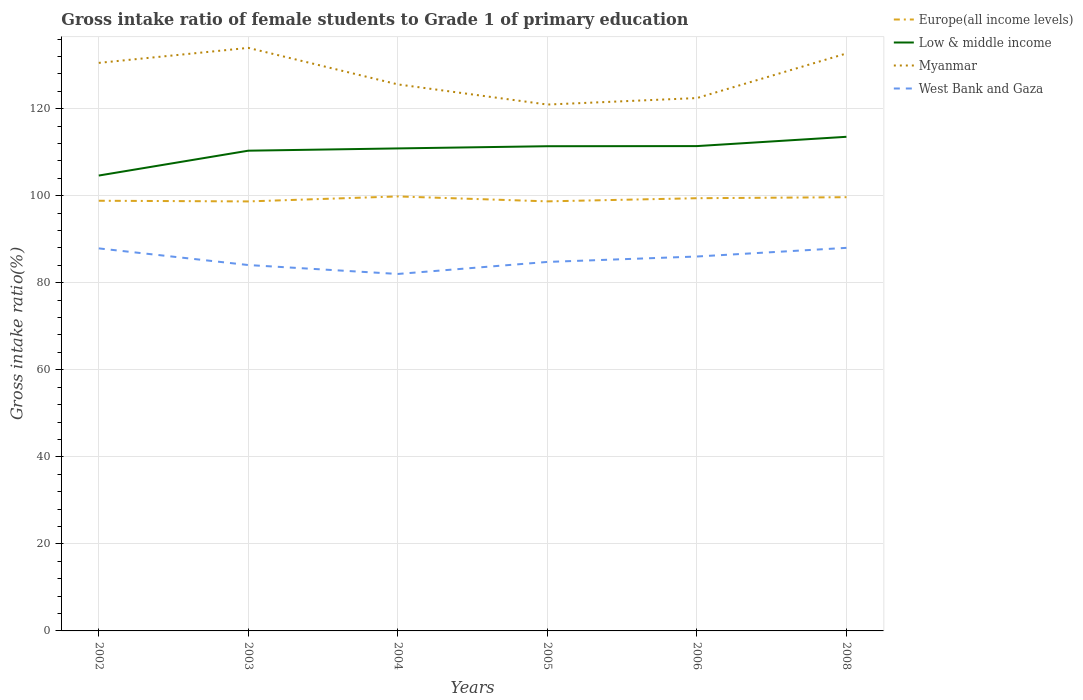How many different coloured lines are there?
Your answer should be compact. 4. Is the number of lines equal to the number of legend labels?
Offer a terse response. Yes. Across all years, what is the maximum gross intake ratio in Europe(all income levels)?
Give a very brief answer. 98.68. What is the total gross intake ratio in Low & middle income in the graph?
Keep it short and to the point. -1.03. What is the difference between the highest and the second highest gross intake ratio in Myanmar?
Offer a very short reply. 13.02. What is the difference between the highest and the lowest gross intake ratio in Low & middle income?
Provide a succinct answer. 4. Is the gross intake ratio in West Bank and Gaza strictly greater than the gross intake ratio in Myanmar over the years?
Give a very brief answer. Yes. How many years are there in the graph?
Ensure brevity in your answer.  6. What is the difference between two consecutive major ticks on the Y-axis?
Offer a very short reply. 20. Are the values on the major ticks of Y-axis written in scientific E-notation?
Keep it short and to the point. No. Does the graph contain grids?
Offer a terse response. Yes. Where does the legend appear in the graph?
Your answer should be very brief. Top right. How many legend labels are there?
Give a very brief answer. 4. What is the title of the graph?
Offer a very short reply. Gross intake ratio of female students to Grade 1 of primary education. What is the label or title of the Y-axis?
Provide a succinct answer. Gross intake ratio(%). What is the Gross intake ratio(%) of Europe(all income levels) in 2002?
Your answer should be very brief. 98.84. What is the Gross intake ratio(%) in Low & middle income in 2002?
Provide a short and direct response. 104.63. What is the Gross intake ratio(%) in Myanmar in 2002?
Give a very brief answer. 130.52. What is the Gross intake ratio(%) in West Bank and Gaza in 2002?
Your response must be concise. 87.89. What is the Gross intake ratio(%) in Europe(all income levels) in 2003?
Give a very brief answer. 98.68. What is the Gross intake ratio(%) in Low & middle income in 2003?
Give a very brief answer. 110.34. What is the Gross intake ratio(%) of Myanmar in 2003?
Keep it short and to the point. 133.96. What is the Gross intake ratio(%) in West Bank and Gaza in 2003?
Offer a terse response. 84.07. What is the Gross intake ratio(%) in Europe(all income levels) in 2004?
Give a very brief answer. 99.83. What is the Gross intake ratio(%) of Low & middle income in 2004?
Offer a very short reply. 110.86. What is the Gross intake ratio(%) in Myanmar in 2004?
Offer a very short reply. 125.57. What is the Gross intake ratio(%) of West Bank and Gaza in 2004?
Your response must be concise. 82.02. What is the Gross intake ratio(%) of Europe(all income levels) in 2005?
Your response must be concise. 98.7. What is the Gross intake ratio(%) in Low & middle income in 2005?
Offer a terse response. 111.37. What is the Gross intake ratio(%) of Myanmar in 2005?
Provide a succinct answer. 120.94. What is the Gross intake ratio(%) of West Bank and Gaza in 2005?
Your answer should be very brief. 84.78. What is the Gross intake ratio(%) of Europe(all income levels) in 2006?
Keep it short and to the point. 99.42. What is the Gross intake ratio(%) in Low & middle income in 2006?
Offer a very short reply. 111.4. What is the Gross intake ratio(%) in Myanmar in 2006?
Provide a succinct answer. 122.43. What is the Gross intake ratio(%) of West Bank and Gaza in 2006?
Offer a terse response. 86.03. What is the Gross intake ratio(%) in Europe(all income levels) in 2008?
Your response must be concise. 99.66. What is the Gross intake ratio(%) in Low & middle income in 2008?
Your response must be concise. 113.53. What is the Gross intake ratio(%) of Myanmar in 2008?
Provide a short and direct response. 132.68. What is the Gross intake ratio(%) of West Bank and Gaza in 2008?
Your answer should be very brief. 88.01. Across all years, what is the maximum Gross intake ratio(%) of Europe(all income levels)?
Make the answer very short. 99.83. Across all years, what is the maximum Gross intake ratio(%) in Low & middle income?
Your answer should be compact. 113.53. Across all years, what is the maximum Gross intake ratio(%) of Myanmar?
Keep it short and to the point. 133.96. Across all years, what is the maximum Gross intake ratio(%) of West Bank and Gaza?
Your answer should be compact. 88.01. Across all years, what is the minimum Gross intake ratio(%) of Europe(all income levels)?
Offer a very short reply. 98.68. Across all years, what is the minimum Gross intake ratio(%) of Low & middle income?
Your answer should be very brief. 104.63. Across all years, what is the minimum Gross intake ratio(%) in Myanmar?
Your answer should be compact. 120.94. Across all years, what is the minimum Gross intake ratio(%) in West Bank and Gaza?
Your response must be concise. 82.02. What is the total Gross intake ratio(%) in Europe(all income levels) in the graph?
Offer a very short reply. 595.13. What is the total Gross intake ratio(%) of Low & middle income in the graph?
Your answer should be compact. 662.13. What is the total Gross intake ratio(%) of Myanmar in the graph?
Your answer should be compact. 766.11. What is the total Gross intake ratio(%) in West Bank and Gaza in the graph?
Provide a short and direct response. 512.8. What is the difference between the Gross intake ratio(%) in Europe(all income levels) in 2002 and that in 2003?
Give a very brief answer. 0.15. What is the difference between the Gross intake ratio(%) of Low & middle income in 2002 and that in 2003?
Ensure brevity in your answer.  -5.71. What is the difference between the Gross intake ratio(%) in Myanmar in 2002 and that in 2003?
Keep it short and to the point. -3.45. What is the difference between the Gross intake ratio(%) in West Bank and Gaza in 2002 and that in 2003?
Keep it short and to the point. 3.83. What is the difference between the Gross intake ratio(%) in Europe(all income levels) in 2002 and that in 2004?
Ensure brevity in your answer.  -0.99. What is the difference between the Gross intake ratio(%) in Low & middle income in 2002 and that in 2004?
Keep it short and to the point. -6.23. What is the difference between the Gross intake ratio(%) in Myanmar in 2002 and that in 2004?
Give a very brief answer. 4.94. What is the difference between the Gross intake ratio(%) of West Bank and Gaza in 2002 and that in 2004?
Provide a short and direct response. 5.88. What is the difference between the Gross intake ratio(%) of Europe(all income levels) in 2002 and that in 2005?
Provide a short and direct response. 0.14. What is the difference between the Gross intake ratio(%) of Low & middle income in 2002 and that in 2005?
Offer a terse response. -6.74. What is the difference between the Gross intake ratio(%) of Myanmar in 2002 and that in 2005?
Your answer should be compact. 9.57. What is the difference between the Gross intake ratio(%) in West Bank and Gaza in 2002 and that in 2005?
Ensure brevity in your answer.  3.11. What is the difference between the Gross intake ratio(%) in Europe(all income levels) in 2002 and that in 2006?
Give a very brief answer. -0.58. What is the difference between the Gross intake ratio(%) in Low & middle income in 2002 and that in 2006?
Your response must be concise. -6.77. What is the difference between the Gross intake ratio(%) of Myanmar in 2002 and that in 2006?
Provide a short and direct response. 8.08. What is the difference between the Gross intake ratio(%) in West Bank and Gaza in 2002 and that in 2006?
Your response must be concise. 1.87. What is the difference between the Gross intake ratio(%) in Europe(all income levels) in 2002 and that in 2008?
Provide a succinct answer. -0.82. What is the difference between the Gross intake ratio(%) in Low & middle income in 2002 and that in 2008?
Offer a very short reply. -8.9. What is the difference between the Gross intake ratio(%) of Myanmar in 2002 and that in 2008?
Your answer should be very brief. -2.17. What is the difference between the Gross intake ratio(%) in West Bank and Gaza in 2002 and that in 2008?
Make the answer very short. -0.12. What is the difference between the Gross intake ratio(%) in Europe(all income levels) in 2003 and that in 2004?
Give a very brief answer. -1.15. What is the difference between the Gross intake ratio(%) in Low & middle income in 2003 and that in 2004?
Your response must be concise. -0.52. What is the difference between the Gross intake ratio(%) in Myanmar in 2003 and that in 2004?
Offer a terse response. 8.39. What is the difference between the Gross intake ratio(%) in West Bank and Gaza in 2003 and that in 2004?
Your answer should be compact. 2.05. What is the difference between the Gross intake ratio(%) in Europe(all income levels) in 2003 and that in 2005?
Offer a very short reply. -0.01. What is the difference between the Gross intake ratio(%) in Low & middle income in 2003 and that in 2005?
Give a very brief answer. -1.03. What is the difference between the Gross intake ratio(%) in Myanmar in 2003 and that in 2005?
Give a very brief answer. 13.02. What is the difference between the Gross intake ratio(%) of West Bank and Gaza in 2003 and that in 2005?
Make the answer very short. -0.71. What is the difference between the Gross intake ratio(%) in Europe(all income levels) in 2003 and that in 2006?
Ensure brevity in your answer.  -0.74. What is the difference between the Gross intake ratio(%) in Low & middle income in 2003 and that in 2006?
Give a very brief answer. -1.06. What is the difference between the Gross intake ratio(%) of Myanmar in 2003 and that in 2006?
Provide a short and direct response. 11.53. What is the difference between the Gross intake ratio(%) of West Bank and Gaza in 2003 and that in 2006?
Make the answer very short. -1.96. What is the difference between the Gross intake ratio(%) in Europe(all income levels) in 2003 and that in 2008?
Make the answer very short. -0.97. What is the difference between the Gross intake ratio(%) of Low & middle income in 2003 and that in 2008?
Offer a terse response. -3.19. What is the difference between the Gross intake ratio(%) of Myanmar in 2003 and that in 2008?
Offer a terse response. 1.28. What is the difference between the Gross intake ratio(%) in West Bank and Gaza in 2003 and that in 2008?
Ensure brevity in your answer.  -3.95. What is the difference between the Gross intake ratio(%) in Europe(all income levels) in 2004 and that in 2005?
Provide a succinct answer. 1.14. What is the difference between the Gross intake ratio(%) in Low & middle income in 2004 and that in 2005?
Make the answer very short. -0.51. What is the difference between the Gross intake ratio(%) of Myanmar in 2004 and that in 2005?
Ensure brevity in your answer.  4.63. What is the difference between the Gross intake ratio(%) in West Bank and Gaza in 2004 and that in 2005?
Keep it short and to the point. -2.76. What is the difference between the Gross intake ratio(%) in Europe(all income levels) in 2004 and that in 2006?
Ensure brevity in your answer.  0.41. What is the difference between the Gross intake ratio(%) of Low & middle income in 2004 and that in 2006?
Provide a succinct answer. -0.53. What is the difference between the Gross intake ratio(%) of Myanmar in 2004 and that in 2006?
Ensure brevity in your answer.  3.14. What is the difference between the Gross intake ratio(%) of West Bank and Gaza in 2004 and that in 2006?
Provide a succinct answer. -4.01. What is the difference between the Gross intake ratio(%) of Europe(all income levels) in 2004 and that in 2008?
Make the answer very short. 0.18. What is the difference between the Gross intake ratio(%) of Low & middle income in 2004 and that in 2008?
Provide a short and direct response. -2.67. What is the difference between the Gross intake ratio(%) in Myanmar in 2004 and that in 2008?
Ensure brevity in your answer.  -7.11. What is the difference between the Gross intake ratio(%) of West Bank and Gaza in 2004 and that in 2008?
Offer a terse response. -6. What is the difference between the Gross intake ratio(%) of Europe(all income levels) in 2005 and that in 2006?
Your answer should be very brief. -0.72. What is the difference between the Gross intake ratio(%) in Low & middle income in 2005 and that in 2006?
Offer a terse response. -0.03. What is the difference between the Gross intake ratio(%) of Myanmar in 2005 and that in 2006?
Offer a very short reply. -1.49. What is the difference between the Gross intake ratio(%) of West Bank and Gaza in 2005 and that in 2006?
Offer a very short reply. -1.24. What is the difference between the Gross intake ratio(%) in Europe(all income levels) in 2005 and that in 2008?
Offer a very short reply. -0.96. What is the difference between the Gross intake ratio(%) in Low & middle income in 2005 and that in 2008?
Your answer should be very brief. -2.16. What is the difference between the Gross intake ratio(%) of Myanmar in 2005 and that in 2008?
Keep it short and to the point. -11.74. What is the difference between the Gross intake ratio(%) in West Bank and Gaza in 2005 and that in 2008?
Your answer should be very brief. -3.23. What is the difference between the Gross intake ratio(%) of Europe(all income levels) in 2006 and that in 2008?
Your response must be concise. -0.23. What is the difference between the Gross intake ratio(%) in Low & middle income in 2006 and that in 2008?
Provide a short and direct response. -2.14. What is the difference between the Gross intake ratio(%) in Myanmar in 2006 and that in 2008?
Offer a terse response. -10.25. What is the difference between the Gross intake ratio(%) of West Bank and Gaza in 2006 and that in 2008?
Offer a very short reply. -1.99. What is the difference between the Gross intake ratio(%) of Europe(all income levels) in 2002 and the Gross intake ratio(%) of Low & middle income in 2003?
Your answer should be very brief. -11.5. What is the difference between the Gross intake ratio(%) of Europe(all income levels) in 2002 and the Gross intake ratio(%) of Myanmar in 2003?
Your answer should be very brief. -35.12. What is the difference between the Gross intake ratio(%) of Europe(all income levels) in 2002 and the Gross intake ratio(%) of West Bank and Gaza in 2003?
Ensure brevity in your answer.  14.77. What is the difference between the Gross intake ratio(%) of Low & middle income in 2002 and the Gross intake ratio(%) of Myanmar in 2003?
Your answer should be very brief. -29.33. What is the difference between the Gross intake ratio(%) in Low & middle income in 2002 and the Gross intake ratio(%) in West Bank and Gaza in 2003?
Your response must be concise. 20.56. What is the difference between the Gross intake ratio(%) in Myanmar in 2002 and the Gross intake ratio(%) in West Bank and Gaza in 2003?
Offer a terse response. 46.45. What is the difference between the Gross intake ratio(%) of Europe(all income levels) in 2002 and the Gross intake ratio(%) of Low & middle income in 2004?
Your response must be concise. -12.03. What is the difference between the Gross intake ratio(%) of Europe(all income levels) in 2002 and the Gross intake ratio(%) of Myanmar in 2004?
Keep it short and to the point. -26.73. What is the difference between the Gross intake ratio(%) of Europe(all income levels) in 2002 and the Gross intake ratio(%) of West Bank and Gaza in 2004?
Your answer should be compact. 16.82. What is the difference between the Gross intake ratio(%) of Low & middle income in 2002 and the Gross intake ratio(%) of Myanmar in 2004?
Offer a very short reply. -20.94. What is the difference between the Gross intake ratio(%) of Low & middle income in 2002 and the Gross intake ratio(%) of West Bank and Gaza in 2004?
Your answer should be very brief. 22.61. What is the difference between the Gross intake ratio(%) in Myanmar in 2002 and the Gross intake ratio(%) in West Bank and Gaza in 2004?
Ensure brevity in your answer.  48.5. What is the difference between the Gross intake ratio(%) in Europe(all income levels) in 2002 and the Gross intake ratio(%) in Low & middle income in 2005?
Give a very brief answer. -12.53. What is the difference between the Gross intake ratio(%) of Europe(all income levels) in 2002 and the Gross intake ratio(%) of Myanmar in 2005?
Offer a very short reply. -22.1. What is the difference between the Gross intake ratio(%) of Europe(all income levels) in 2002 and the Gross intake ratio(%) of West Bank and Gaza in 2005?
Keep it short and to the point. 14.06. What is the difference between the Gross intake ratio(%) in Low & middle income in 2002 and the Gross intake ratio(%) in Myanmar in 2005?
Keep it short and to the point. -16.31. What is the difference between the Gross intake ratio(%) of Low & middle income in 2002 and the Gross intake ratio(%) of West Bank and Gaza in 2005?
Offer a very short reply. 19.85. What is the difference between the Gross intake ratio(%) of Myanmar in 2002 and the Gross intake ratio(%) of West Bank and Gaza in 2005?
Keep it short and to the point. 45.73. What is the difference between the Gross intake ratio(%) in Europe(all income levels) in 2002 and the Gross intake ratio(%) in Low & middle income in 2006?
Provide a short and direct response. -12.56. What is the difference between the Gross intake ratio(%) in Europe(all income levels) in 2002 and the Gross intake ratio(%) in Myanmar in 2006?
Provide a succinct answer. -23.6. What is the difference between the Gross intake ratio(%) in Europe(all income levels) in 2002 and the Gross intake ratio(%) in West Bank and Gaza in 2006?
Provide a succinct answer. 12.81. What is the difference between the Gross intake ratio(%) of Low & middle income in 2002 and the Gross intake ratio(%) of Myanmar in 2006?
Your answer should be very brief. -17.81. What is the difference between the Gross intake ratio(%) of Low & middle income in 2002 and the Gross intake ratio(%) of West Bank and Gaza in 2006?
Your response must be concise. 18.6. What is the difference between the Gross intake ratio(%) of Myanmar in 2002 and the Gross intake ratio(%) of West Bank and Gaza in 2006?
Make the answer very short. 44.49. What is the difference between the Gross intake ratio(%) of Europe(all income levels) in 2002 and the Gross intake ratio(%) of Low & middle income in 2008?
Your response must be concise. -14.69. What is the difference between the Gross intake ratio(%) in Europe(all income levels) in 2002 and the Gross intake ratio(%) in Myanmar in 2008?
Make the answer very short. -33.84. What is the difference between the Gross intake ratio(%) in Europe(all income levels) in 2002 and the Gross intake ratio(%) in West Bank and Gaza in 2008?
Offer a very short reply. 10.82. What is the difference between the Gross intake ratio(%) of Low & middle income in 2002 and the Gross intake ratio(%) of Myanmar in 2008?
Provide a short and direct response. -28.05. What is the difference between the Gross intake ratio(%) in Low & middle income in 2002 and the Gross intake ratio(%) in West Bank and Gaza in 2008?
Keep it short and to the point. 16.61. What is the difference between the Gross intake ratio(%) of Myanmar in 2002 and the Gross intake ratio(%) of West Bank and Gaza in 2008?
Provide a succinct answer. 42.5. What is the difference between the Gross intake ratio(%) of Europe(all income levels) in 2003 and the Gross intake ratio(%) of Low & middle income in 2004?
Your answer should be very brief. -12.18. What is the difference between the Gross intake ratio(%) in Europe(all income levels) in 2003 and the Gross intake ratio(%) in Myanmar in 2004?
Offer a very short reply. -26.89. What is the difference between the Gross intake ratio(%) in Europe(all income levels) in 2003 and the Gross intake ratio(%) in West Bank and Gaza in 2004?
Make the answer very short. 16.67. What is the difference between the Gross intake ratio(%) in Low & middle income in 2003 and the Gross intake ratio(%) in Myanmar in 2004?
Provide a short and direct response. -15.23. What is the difference between the Gross intake ratio(%) in Low & middle income in 2003 and the Gross intake ratio(%) in West Bank and Gaza in 2004?
Offer a very short reply. 28.32. What is the difference between the Gross intake ratio(%) of Myanmar in 2003 and the Gross intake ratio(%) of West Bank and Gaza in 2004?
Make the answer very short. 51.95. What is the difference between the Gross intake ratio(%) of Europe(all income levels) in 2003 and the Gross intake ratio(%) of Low & middle income in 2005?
Provide a succinct answer. -12.69. What is the difference between the Gross intake ratio(%) in Europe(all income levels) in 2003 and the Gross intake ratio(%) in Myanmar in 2005?
Ensure brevity in your answer.  -22.26. What is the difference between the Gross intake ratio(%) in Europe(all income levels) in 2003 and the Gross intake ratio(%) in West Bank and Gaza in 2005?
Provide a succinct answer. 13.9. What is the difference between the Gross intake ratio(%) in Low & middle income in 2003 and the Gross intake ratio(%) in Myanmar in 2005?
Provide a succinct answer. -10.6. What is the difference between the Gross intake ratio(%) of Low & middle income in 2003 and the Gross intake ratio(%) of West Bank and Gaza in 2005?
Your response must be concise. 25.56. What is the difference between the Gross intake ratio(%) in Myanmar in 2003 and the Gross intake ratio(%) in West Bank and Gaza in 2005?
Keep it short and to the point. 49.18. What is the difference between the Gross intake ratio(%) in Europe(all income levels) in 2003 and the Gross intake ratio(%) in Low & middle income in 2006?
Ensure brevity in your answer.  -12.71. What is the difference between the Gross intake ratio(%) in Europe(all income levels) in 2003 and the Gross intake ratio(%) in Myanmar in 2006?
Your answer should be compact. -23.75. What is the difference between the Gross intake ratio(%) in Europe(all income levels) in 2003 and the Gross intake ratio(%) in West Bank and Gaza in 2006?
Offer a very short reply. 12.66. What is the difference between the Gross intake ratio(%) in Low & middle income in 2003 and the Gross intake ratio(%) in Myanmar in 2006?
Offer a very short reply. -12.09. What is the difference between the Gross intake ratio(%) in Low & middle income in 2003 and the Gross intake ratio(%) in West Bank and Gaza in 2006?
Ensure brevity in your answer.  24.32. What is the difference between the Gross intake ratio(%) in Myanmar in 2003 and the Gross intake ratio(%) in West Bank and Gaza in 2006?
Keep it short and to the point. 47.94. What is the difference between the Gross intake ratio(%) in Europe(all income levels) in 2003 and the Gross intake ratio(%) in Low & middle income in 2008?
Provide a short and direct response. -14.85. What is the difference between the Gross intake ratio(%) in Europe(all income levels) in 2003 and the Gross intake ratio(%) in Myanmar in 2008?
Provide a succinct answer. -34. What is the difference between the Gross intake ratio(%) of Europe(all income levels) in 2003 and the Gross intake ratio(%) of West Bank and Gaza in 2008?
Your answer should be compact. 10.67. What is the difference between the Gross intake ratio(%) in Low & middle income in 2003 and the Gross intake ratio(%) in Myanmar in 2008?
Give a very brief answer. -22.34. What is the difference between the Gross intake ratio(%) in Low & middle income in 2003 and the Gross intake ratio(%) in West Bank and Gaza in 2008?
Provide a short and direct response. 22.33. What is the difference between the Gross intake ratio(%) of Myanmar in 2003 and the Gross intake ratio(%) of West Bank and Gaza in 2008?
Provide a succinct answer. 45.95. What is the difference between the Gross intake ratio(%) of Europe(all income levels) in 2004 and the Gross intake ratio(%) of Low & middle income in 2005?
Provide a succinct answer. -11.54. What is the difference between the Gross intake ratio(%) of Europe(all income levels) in 2004 and the Gross intake ratio(%) of Myanmar in 2005?
Keep it short and to the point. -21.11. What is the difference between the Gross intake ratio(%) in Europe(all income levels) in 2004 and the Gross intake ratio(%) in West Bank and Gaza in 2005?
Your answer should be very brief. 15.05. What is the difference between the Gross intake ratio(%) of Low & middle income in 2004 and the Gross intake ratio(%) of Myanmar in 2005?
Keep it short and to the point. -10.08. What is the difference between the Gross intake ratio(%) in Low & middle income in 2004 and the Gross intake ratio(%) in West Bank and Gaza in 2005?
Ensure brevity in your answer.  26.08. What is the difference between the Gross intake ratio(%) in Myanmar in 2004 and the Gross intake ratio(%) in West Bank and Gaza in 2005?
Keep it short and to the point. 40.79. What is the difference between the Gross intake ratio(%) of Europe(all income levels) in 2004 and the Gross intake ratio(%) of Low & middle income in 2006?
Provide a short and direct response. -11.56. What is the difference between the Gross intake ratio(%) in Europe(all income levels) in 2004 and the Gross intake ratio(%) in Myanmar in 2006?
Offer a very short reply. -22.6. What is the difference between the Gross intake ratio(%) of Europe(all income levels) in 2004 and the Gross intake ratio(%) of West Bank and Gaza in 2006?
Offer a very short reply. 13.81. What is the difference between the Gross intake ratio(%) of Low & middle income in 2004 and the Gross intake ratio(%) of Myanmar in 2006?
Ensure brevity in your answer.  -11.57. What is the difference between the Gross intake ratio(%) of Low & middle income in 2004 and the Gross intake ratio(%) of West Bank and Gaza in 2006?
Provide a short and direct response. 24.84. What is the difference between the Gross intake ratio(%) of Myanmar in 2004 and the Gross intake ratio(%) of West Bank and Gaza in 2006?
Ensure brevity in your answer.  39.55. What is the difference between the Gross intake ratio(%) in Europe(all income levels) in 2004 and the Gross intake ratio(%) in Low & middle income in 2008?
Your answer should be very brief. -13.7. What is the difference between the Gross intake ratio(%) in Europe(all income levels) in 2004 and the Gross intake ratio(%) in Myanmar in 2008?
Your answer should be compact. -32.85. What is the difference between the Gross intake ratio(%) of Europe(all income levels) in 2004 and the Gross intake ratio(%) of West Bank and Gaza in 2008?
Offer a terse response. 11.82. What is the difference between the Gross intake ratio(%) of Low & middle income in 2004 and the Gross intake ratio(%) of Myanmar in 2008?
Give a very brief answer. -21.82. What is the difference between the Gross intake ratio(%) in Low & middle income in 2004 and the Gross intake ratio(%) in West Bank and Gaza in 2008?
Keep it short and to the point. 22.85. What is the difference between the Gross intake ratio(%) of Myanmar in 2004 and the Gross intake ratio(%) of West Bank and Gaza in 2008?
Your answer should be very brief. 37.56. What is the difference between the Gross intake ratio(%) of Europe(all income levels) in 2005 and the Gross intake ratio(%) of Low & middle income in 2006?
Your answer should be compact. -12.7. What is the difference between the Gross intake ratio(%) in Europe(all income levels) in 2005 and the Gross intake ratio(%) in Myanmar in 2006?
Provide a short and direct response. -23.74. What is the difference between the Gross intake ratio(%) of Europe(all income levels) in 2005 and the Gross intake ratio(%) of West Bank and Gaza in 2006?
Keep it short and to the point. 12.67. What is the difference between the Gross intake ratio(%) in Low & middle income in 2005 and the Gross intake ratio(%) in Myanmar in 2006?
Give a very brief answer. -11.07. What is the difference between the Gross intake ratio(%) in Low & middle income in 2005 and the Gross intake ratio(%) in West Bank and Gaza in 2006?
Offer a terse response. 25.34. What is the difference between the Gross intake ratio(%) of Myanmar in 2005 and the Gross intake ratio(%) of West Bank and Gaza in 2006?
Your answer should be very brief. 34.92. What is the difference between the Gross intake ratio(%) in Europe(all income levels) in 2005 and the Gross intake ratio(%) in Low & middle income in 2008?
Ensure brevity in your answer.  -14.84. What is the difference between the Gross intake ratio(%) of Europe(all income levels) in 2005 and the Gross intake ratio(%) of Myanmar in 2008?
Provide a succinct answer. -33.98. What is the difference between the Gross intake ratio(%) of Europe(all income levels) in 2005 and the Gross intake ratio(%) of West Bank and Gaza in 2008?
Your answer should be very brief. 10.68. What is the difference between the Gross intake ratio(%) in Low & middle income in 2005 and the Gross intake ratio(%) in Myanmar in 2008?
Your answer should be very brief. -21.31. What is the difference between the Gross intake ratio(%) in Low & middle income in 2005 and the Gross intake ratio(%) in West Bank and Gaza in 2008?
Your answer should be very brief. 23.35. What is the difference between the Gross intake ratio(%) in Myanmar in 2005 and the Gross intake ratio(%) in West Bank and Gaza in 2008?
Offer a terse response. 32.93. What is the difference between the Gross intake ratio(%) of Europe(all income levels) in 2006 and the Gross intake ratio(%) of Low & middle income in 2008?
Your response must be concise. -14.11. What is the difference between the Gross intake ratio(%) of Europe(all income levels) in 2006 and the Gross intake ratio(%) of Myanmar in 2008?
Your response must be concise. -33.26. What is the difference between the Gross intake ratio(%) of Europe(all income levels) in 2006 and the Gross intake ratio(%) of West Bank and Gaza in 2008?
Your response must be concise. 11.41. What is the difference between the Gross intake ratio(%) of Low & middle income in 2006 and the Gross intake ratio(%) of Myanmar in 2008?
Your answer should be very brief. -21.28. What is the difference between the Gross intake ratio(%) in Low & middle income in 2006 and the Gross intake ratio(%) in West Bank and Gaza in 2008?
Ensure brevity in your answer.  23.38. What is the difference between the Gross intake ratio(%) of Myanmar in 2006 and the Gross intake ratio(%) of West Bank and Gaza in 2008?
Provide a succinct answer. 34.42. What is the average Gross intake ratio(%) in Europe(all income levels) per year?
Your answer should be compact. 99.19. What is the average Gross intake ratio(%) of Low & middle income per year?
Give a very brief answer. 110.36. What is the average Gross intake ratio(%) in Myanmar per year?
Make the answer very short. 127.68. What is the average Gross intake ratio(%) of West Bank and Gaza per year?
Make the answer very short. 85.47. In the year 2002, what is the difference between the Gross intake ratio(%) of Europe(all income levels) and Gross intake ratio(%) of Low & middle income?
Your response must be concise. -5.79. In the year 2002, what is the difference between the Gross intake ratio(%) in Europe(all income levels) and Gross intake ratio(%) in Myanmar?
Keep it short and to the point. -31.68. In the year 2002, what is the difference between the Gross intake ratio(%) in Europe(all income levels) and Gross intake ratio(%) in West Bank and Gaza?
Keep it short and to the point. 10.94. In the year 2002, what is the difference between the Gross intake ratio(%) in Low & middle income and Gross intake ratio(%) in Myanmar?
Offer a very short reply. -25.89. In the year 2002, what is the difference between the Gross intake ratio(%) of Low & middle income and Gross intake ratio(%) of West Bank and Gaza?
Provide a succinct answer. 16.74. In the year 2002, what is the difference between the Gross intake ratio(%) of Myanmar and Gross intake ratio(%) of West Bank and Gaza?
Offer a very short reply. 42.62. In the year 2003, what is the difference between the Gross intake ratio(%) of Europe(all income levels) and Gross intake ratio(%) of Low & middle income?
Provide a succinct answer. -11.66. In the year 2003, what is the difference between the Gross intake ratio(%) in Europe(all income levels) and Gross intake ratio(%) in Myanmar?
Your answer should be very brief. -35.28. In the year 2003, what is the difference between the Gross intake ratio(%) in Europe(all income levels) and Gross intake ratio(%) in West Bank and Gaza?
Your answer should be very brief. 14.62. In the year 2003, what is the difference between the Gross intake ratio(%) of Low & middle income and Gross intake ratio(%) of Myanmar?
Ensure brevity in your answer.  -23.62. In the year 2003, what is the difference between the Gross intake ratio(%) in Low & middle income and Gross intake ratio(%) in West Bank and Gaza?
Provide a short and direct response. 26.27. In the year 2003, what is the difference between the Gross intake ratio(%) of Myanmar and Gross intake ratio(%) of West Bank and Gaza?
Make the answer very short. 49.9. In the year 2004, what is the difference between the Gross intake ratio(%) in Europe(all income levels) and Gross intake ratio(%) in Low & middle income?
Give a very brief answer. -11.03. In the year 2004, what is the difference between the Gross intake ratio(%) in Europe(all income levels) and Gross intake ratio(%) in Myanmar?
Ensure brevity in your answer.  -25.74. In the year 2004, what is the difference between the Gross intake ratio(%) of Europe(all income levels) and Gross intake ratio(%) of West Bank and Gaza?
Your answer should be compact. 17.82. In the year 2004, what is the difference between the Gross intake ratio(%) of Low & middle income and Gross intake ratio(%) of Myanmar?
Your answer should be very brief. -14.71. In the year 2004, what is the difference between the Gross intake ratio(%) in Low & middle income and Gross intake ratio(%) in West Bank and Gaza?
Make the answer very short. 28.85. In the year 2004, what is the difference between the Gross intake ratio(%) in Myanmar and Gross intake ratio(%) in West Bank and Gaza?
Provide a succinct answer. 43.55. In the year 2005, what is the difference between the Gross intake ratio(%) of Europe(all income levels) and Gross intake ratio(%) of Low & middle income?
Provide a short and direct response. -12.67. In the year 2005, what is the difference between the Gross intake ratio(%) in Europe(all income levels) and Gross intake ratio(%) in Myanmar?
Make the answer very short. -22.24. In the year 2005, what is the difference between the Gross intake ratio(%) of Europe(all income levels) and Gross intake ratio(%) of West Bank and Gaza?
Provide a succinct answer. 13.92. In the year 2005, what is the difference between the Gross intake ratio(%) in Low & middle income and Gross intake ratio(%) in Myanmar?
Give a very brief answer. -9.57. In the year 2005, what is the difference between the Gross intake ratio(%) in Low & middle income and Gross intake ratio(%) in West Bank and Gaza?
Provide a succinct answer. 26.59. In the year 2005, what is the difference between the Gross intake ratio(%) in Myanmar and Gross intake ratio(%) in West Bank and Gaza?
Offer a very short reply. 36.16. In the year 2006, what is the difference between the Gross intake ratio(%) in Europe(all income levels) and Gross intake ratio(%) in Low & middle income?
Keep it short and to the point. -11.98. In the year 2006, what is the difference between the Gross intake ratio(%) in Europe(all income levels) and Gross intake ratio(%) in Myanmar?
Provide a succinct answer. -23.01. In the year 2006, what is the difference between the Gross intake ratio(%) of Europe(all income levels) and Gross intake ratio(%) of West Bank and Gaza?
Provide a short and direct response. 13.39. In the year 2006, what is the difference between the Gross intake ratio(%) of Low & middle income and Gross intake ratio(%) of Myanmar?
Keep it short and to the point. -11.04. In the year 2006, what is the difference between the Gross intake ratio(%) in Low & middle income and Gross intake ratio(%) in West Bank and Gaza?
Offer a terse response. 25.37. In the year 2006, what is the difference between the Gross intake ratio(%) of Myanmar and Gross intake ratio(%) of West Bank and Gaza?
Your answer should be very brief. 36.41. In the year 2008, what is the difference between the Gross intake ratio(%) of Europe(all income levels) and Gross intake ratio(%) of Low & middle income?
Provide a short and direct response. -13.88. In the year 2008, what is the difference between the Gross intake ratio(%) of Europe(all income levels) and Gross intake ratio(%) of Myanmar?
Offer a very short reply. -33.03. In the year 2008, what is the difference between the Gross intake ratio(%) in Europe(all income levels) and Gross intake ratio(%) in West Bank and Gaza?
Make the answer very short. 11.64. In the year 2008, what is the difference between the Gross intake ratio(%) in Low & middle income and Gross intake ratio(%) in Myanmar?
Your answer should be compact. -19.15. In the year 2008, what is the difference between the Gross intake ratio(%) in Low & middle income and Gross intake ratio(%) in West Bank and Gaza?
Offer a terse response. 25.52. In the year 2008, what is the difference between the Gross intake ratio(%) in Myanmar and Gross intake ratio(%) in West Bank and Gaza?
Make the answer very short. 44.67. What is the ratio of the Gross intake ratio(%) in Low & middle income in 2002 to that in 2003?
Offer a very short reply. 0.95. What is the ratio of the Gross intake ratio(%) of Myanmar in 2002 to that in 2003?
Your answer should be compact. 0.97. What is the ratio of the Gross intake ratio(%) of West Bank and Gaza in 2002 to that in 2003?
Offer a very short reply. 1.05. What is the ratio of the Gross intake ratio(%) in Low & middle income in 2002 to that in 2004?
Offer a terse response. 0.94. What is the ratio of the Gross intake ratio(%) of Myanmar in 2002 to that in 2004?
Your answer should be compact. 1.04. What is the ratio of the Gross intake ratio(%) of West Bank and Gaza in 2002 to that in 2004?
Your answer should be very brief. 1.07. What is the ratio of the Gross intake ratio(%) in Low & middle income in 2002 to that in 2005?
Your answer should be very brief. 0.94. What is the ratio of the Gross intake ratio(%) in Myanmar in 2002 to that in 2005?
Your response must be concise. 1.08. What is the ratio of the Gross intake ratio(%) of West Bank and Gaza in 2002 to that in 2005?
Offer a terse response. 1.04. What is the ratio of the Gross intake ratio(%) of Europe(all income levels) in 2002 to that in 2006?
Give a very brief answer. 0.99. What is the ratio of the Gross intake ratio(%) in Low & middle income in 2002 to that in 2006?
Offer a terse response. 0.94. What is the ratio of the Gross intake ratio(%) in Myanmar in 2002 to that in 2006?
Provide a succinct answer. 1.07. What is the ratio of the Gross intake ratio(%) in West Bank and Gaza in 2002 to that in 2006?
Your response must be concise. 1.02. What is the ratio of the Gross intake ratio(%) of Low & middle income in 2002 to that in 2008?
Keep it short and to the point. 0.92. What is the ratio of the Gross intake ratio(%) of Myanmar in 2002 to that in 2008?
Your response must be concise. 0.98. What is the ratio of the Gross intake ratio(%) of West Bank and Gaza in 2002 to that in 2008?
Offer a very short reply. 1. What is the ratio of the Gross intake ratio(%) of Europe(all income levels) in 2003 to that in 2004?
Your response must be concise. 0.99. What is the ratio of the Gross intake ratio(%) of Low & middle income in 2003 to that in 2004?
Provide a short and direct response. 1. What is the ratio of the Gross intake ratio(%) in Myanmar in 2003 to that in 2004?
Keep it short and to the point. 1.07. What is the ratio of the Gross intake ratio(%) in West Bank and Gaza in 2003 to that in 2004?
Your answer should be very brief. 1.02. What is the ratio of the Gross intake ratio(%) in Low & middle income in 2003 to that in 2005?
Your answer should be compact. 0.99. What is the ratio of the Gross intake ratio(%) in Myanmar in 2003 to that in 2005?
Offer a very short reply. 1.11. What is the ratio of the Gross intake ratio(%) of West Bank and Gaza in 2003 to that in 2005?
Keep it short and to the point. 0.99. What is the ratio of the Gross intake ratio(%) of Myanmar in 2003 to that in 2006?
Offer a very short reply. 1.09. What is the ratio of the Gross intake ratio(%) of West Bank and Gaza in 2003 to that in 2006?
Your response must be concise. 0.98. What is the ratio of the Gross intake ratio(%) of Europe(all income levels) in 2003 to that in 2008?
Offer a very short reply. 0.99. What is the ratio of the Gross intake ratio(%) of Low & middle income in 2003 to that in 2008?
Your answer should be compact. 0.97. What is the ratio of the Gross intake ratio(%) in Myanmar in 2003 to that in 2008?
Offer a very short reply. 1.01. What is the ratio of the Gross intake ratio(%) of West Bank and Gaza in 2003 to that in 2008?
Your answer should be compact. 0.96. What is the ratio of the Gross intake ratio(%) in Europe(all income levels) in 2004 to that in 2005?
Your response must be concise. 1.01. What is the ratio of the Gross intake ratio(%) of Myanmar in 2004 to that in 2005?
Your response must be concise. 1.04. What is the ratio of the Gross intake ratio(%) in West Bank and Gaza in 2004 to that in 2005?
Offer a terse response. 0.97. What is the ratio of the Gross intake ratio(%) in Europe(all income levels) in 2004 to that in 2006?
Keep it short and to the point. 1. What is the ratio of the Gross intake ratio(%) of Low & middle income in 2004 to that in 2006?
Ensure brevity in your answer.  1. What is the ratio of the Gross intake ratio(%) of Myanmar in 2004 to that in 2006?
Your response must be concise. 1.03. What is the ratio of the Gross intake ratio(%) of West Bank and Gaza in 2004 to that in 2006?
Give a very brief answer. 0.95. What is the ratio of the Gross intake ratio(%) in Low & middle income in 2004 to that in 2008?
Give a very brief answer. 0.98. What is the ratio of the Gross intake ratio(%) in Myanmar in 2004 to that in 2008?
Offer a terse response. 0.95. What is the ratio of the Gross intake ratio(%) in West Bank and Gaza in 2004 to that in 2008?
Your response must be concise. 0.93. What is the ratio of the Gross intake ratio(%) in Europe(all income levels) in 2005 to that in 2006?
Ensure brevity in your answer.  0.99. What is the ratio of the Gross intake ratio(%) in Low & middle income in 2005 to that in 2006?
Ensure brevity in your answer.  1. What is the ratio of the Gross intake ratio(%) of West Bank and Gaza in 2005 to that in 2006?
Your answer should be very brief. 0.99. What is the ratio of the Gross intake ratio(%) in Europe(all income levels) in 2005 to that in 2008?
Give a very brief answer. 0.99. What is the ratio of the Gross intake ratio(%) of Low & middle income in 2005 to that in 2008?
Your answer should be very brief. 0.98. What is the ratio of the Gross intake ratio(%) of Myanmar in 2005 to that in 2008?
Keep it short and to the point. 0.91. What is the ratio of the Gross intake ratio(%) of West Bank and Gaza in 2005 to that in 2008?
Make the answer very short. 0.96. What is the ratio of the Gross intake ratio(%) in Low & middle income in 2006 to that in 2008?
Offer a very short reply. 0.98. What is the ratio of the Gross intake ratio(%) in Myanmar in 2006 to that in 2008?
Provide a succinct answer. 0.92. What is the ratio of the Gross intake ratio(%) in West Bank and Gaza in 2006 to that in 2008?
Give a very brief answer. 0.98. What is the difference between the highest and the second highest Gross intake ratio(%) of Europe(all income levels)?
Provide a short and direct response. 0.18. What is the difference between the highest and the second highest Gross intake ratio(%) of Low & middle income?
Offer a very short reply. 2.14. What is the difference between the highest and the second highest Gross intake ratio(%) in Myanmar?
Keep it short and to the point. 1.28. What is the difference between the highest and the second highest Gross intake ratio(%) of West Bank and Gaza?
Your response must be concise. 0.12. What is the difference between the highest and the lowest Gross intake ratio(%) of Europe(all income levels)?
Provide a short and direct response. 1.15. What is the difference between the highest and the lowest Gross intake ratio(%) in Low & middle income?
Offer a terse response. 8.9. What is the difference between the highest and the lowest Gross intake ratio(%) of Myanmar?
Your answer should be very brief. 13.02. What is the difference between the highest and the lowest Gross intake ratio(%) in West Bank and Gaza?
Make the answer very short. 6. 